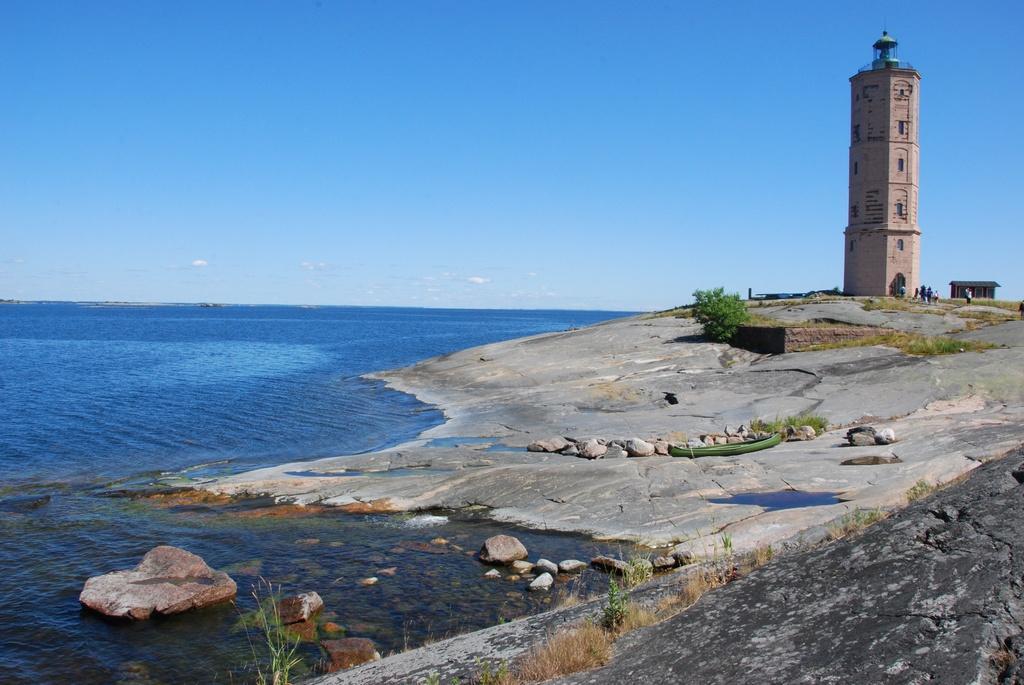Describe this image in one or two sentences. In this picture we can see sea shore, side we can see the tower, few people are standing near tower. 